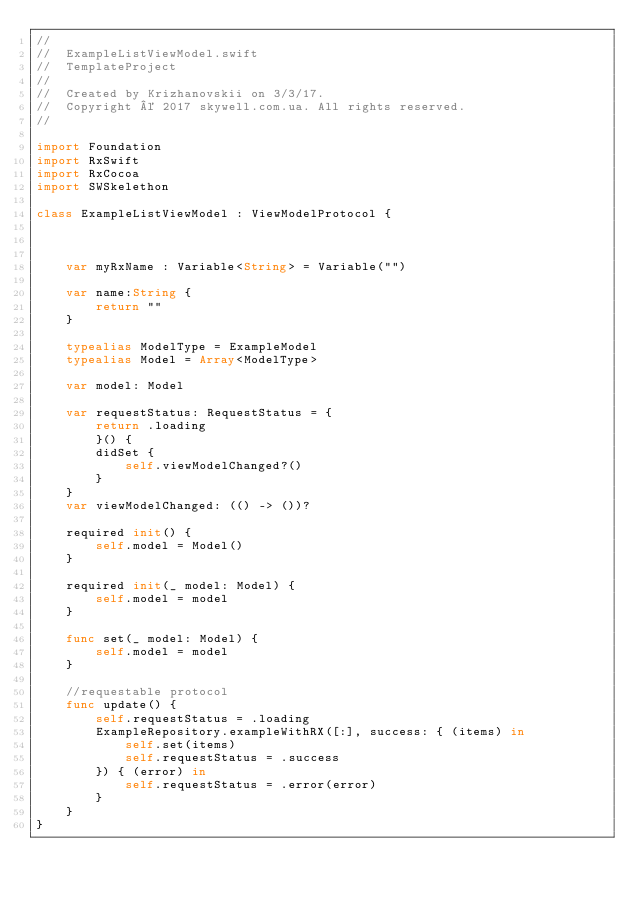<code> <loc_0><loc_0><loc_500><loc_500><_Swift_>//
//  ExampleListViewModel.swift
//  TemplateProject
//
//  Created by Krizhanovskii on 3/3/17.
//  Copyright © 2017 skywell.com.ua. All rights reserved.
//

import Foundation
import RxSwift
import RxCocoa
import SWSkelethon

class ExampleListViewModel : ViewModelProtocol {


    
    var myRxName : Variable<String> = Variable("")
    
    var name:String {
        return ""
    }
    
    typealias ModelType = ExampleModel
    typealias Model = Array<ModelType>
    
    var model: Model
    
    var requestStatus: RequestStatus = {
        return .loading
        }() {
        didSet {
            self.viewModelChanged?()
        }
    }
    var viewModelChanged: (() -> ())?
    
    required init() {
        self.model = Model()
    }
    
    required init(_ model: Model) {
        self.model = model
    }
    
    func set(_ model: Model) {
        self.model = model
    }
    
    //requestable protocol
    func update() {
        self.requestStatus = .loading
        ExampleRepository.exampleWithRX([:], success: { (items) in
            self.set(items)
            self.requestStatus = .success
        }) { (error) in
            self.requestStatus = .error(error)
        }
    }
}
</code> 